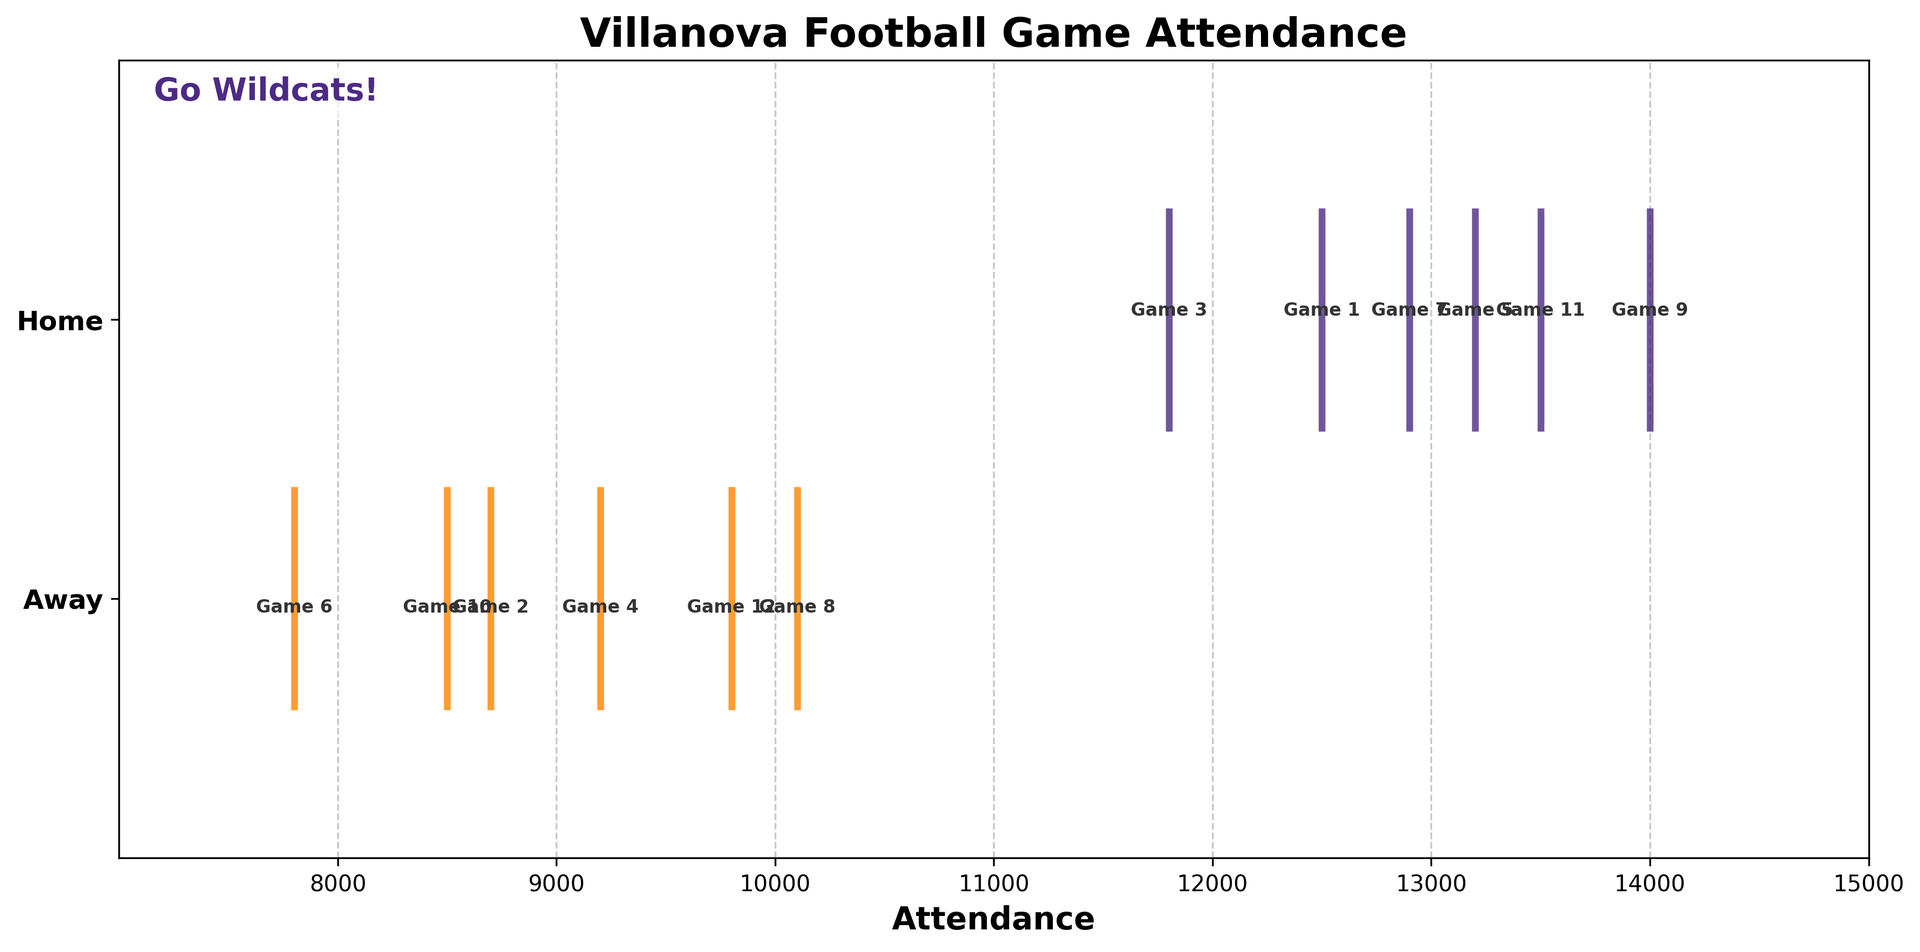Which game had the highest attendance? The figure shows attendance numbers for each game. The highest attendance appears at Game 9.
Answer: Game 9 How does the average attendance of home games compare to away games? Calculate the average attendance for home and away games separately. Home games: (12500 + 11800 + 13200 + 12900 + 14000 + 13500) / 6 = 12983.33. Away games: (8700 + 9200 + 7800 + 10100 + 8500 + 9800) / 6 = 9133.33. Compare both averages.
Answer: Home games have higher average attendance How many games had attendance above 13000? Identify the games with attendance numbers higher than 13000 by examining the positions where the attendance value is over 13000. These values are in Game 5, Game 9, and Game 11.
Answer: 3 games Which location had more variability in game attendance? Assess the spread of attendance values for home and away games. Home attendance ranges from 11800 to 14000, while away attendance ranges from 7800 to 10100. The variability appears larger for home games.
Answer: Home games Which game had the lowest attendance? The figure displays attendances; locate the minimum value. The lowest attendance appears at Game 6.
Answer: Game 6 What is the sum of the attendance for all home games? Add the attendance numbers for all home games: 12500 + 11800 + 13200 + 12900 + 14000 + 13500.
Answer: 77900 How does the highest away game attendance compare to the lowest home game attendance? Identify the highest attendance among away games and the lowest among home games. Highest away game attendance is 10100, and lowest home game attendance is 11800. Compare both values.
Answer: Lowest home game attendance is higher How many home games had attendance greater than 13000? Check the attendance values for home games that exceed 13000. These are Game 9 and Game 11.
Answer: 2 games 